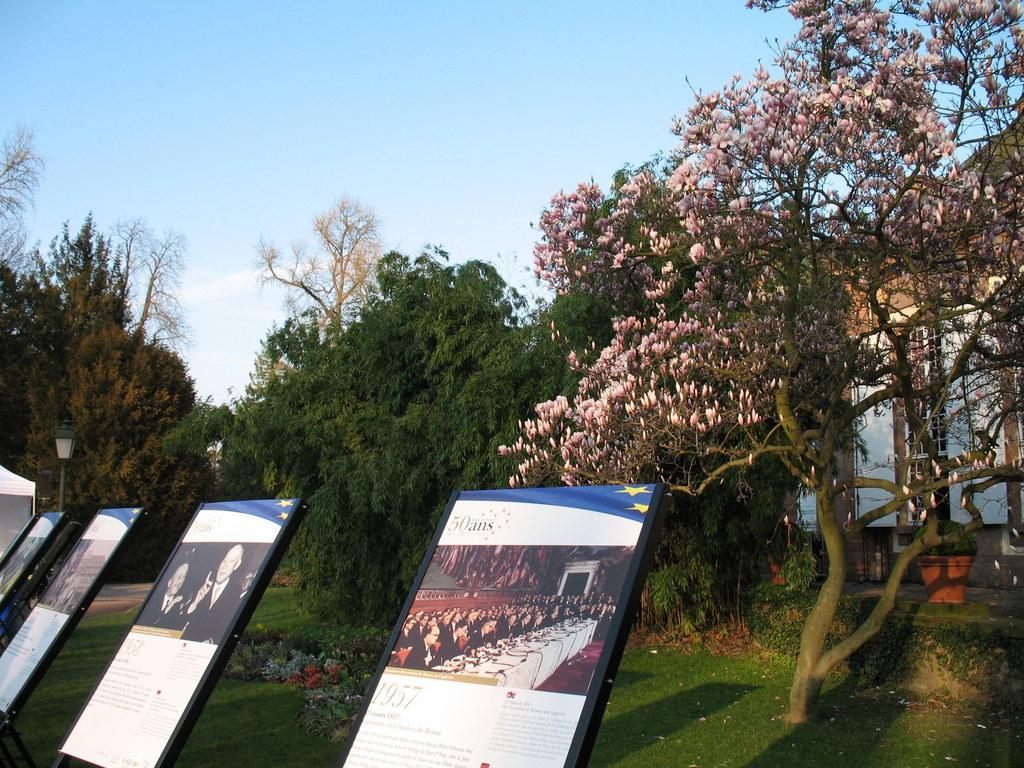Please provide a concise description of this image. There are display boards present at the bottom of this image and there are trees in the background. The sky is at the top of this image. 